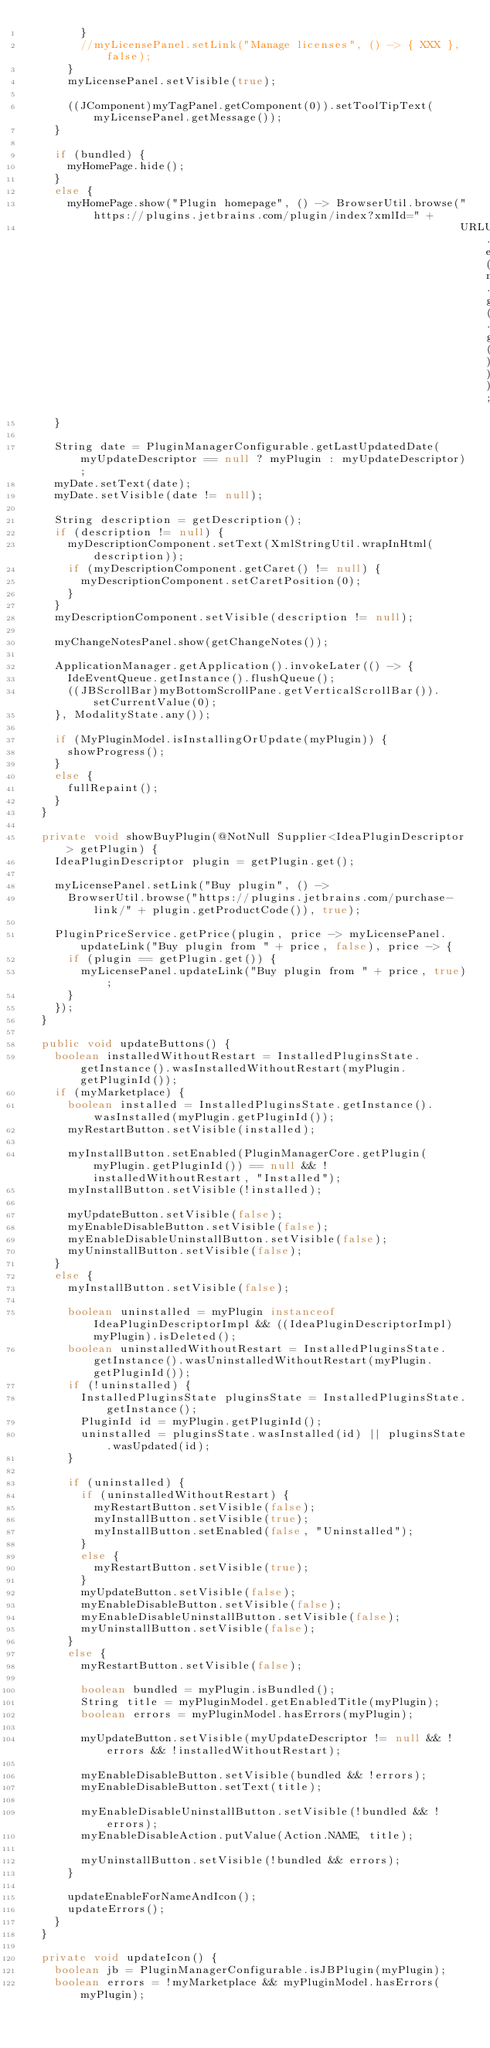<code> <loc_0><loc_0><loc_500><loc_500><_Java_>        }
        //myLicensePanel.setLink("Manage licenses", () -> { XXX }, false);
      }
      myLicensePanel.setVisible(true);

      ((JComponent)myTagPanel.getComponent(0)).setToolTipText(myLicensePanel.getMessage());
    }

    if (bundled) {
      myHomePage.hide();
    }
    else {
      myHomePage.show("Plugin homepage", () -> BrowserUtil.browse("https://plugins.jetbrains.com/plugin/index?xmlId=" +
                                                                  URLUtil.encodeURIComponent(myPlugin.getPluginId().getIdString())));
    }

    String date = PluginManagerConfigurable.getLastUpdatedDate(myUpdateDescriptor == null ? myPlugin : myUpdateDescriptor);
    myDate.setText(date);
    myDate.setVisible(date != null);

    String description = getDescription();
    if (description != null) {
      myDescriptionComponent.setText(XmlStringUtil.wrapInHtml(description));
      if (myDescriptionComponent.getCaret() != null) {
        myDescriptionComponent.setCaretPosition(0);
      }
    }
    myDescriptionComponent.setVisible(description != null);

    myChangeNotesPanel.show(getChangeNotes());

    ApplicationManager.getApplication().invokeLater(() -> {
      IdeEventQueue.getInstance().flushQueue();
      ((JBScrollBar)myBottomScrollPane.getVerticalScrollBar()).setCurrentValue(0);
    }, ModalityState.any());

    if (MyPluginModel.isInstallingOrUpdate(myPlugin)) {
      showProgress();
    }
    else {
      fullRepaint();
    }
  }

  private void showBuyPlugin(@NotNull Supplier<IdeaPluginDescriptor> getPlugin) {
    IdeaPluginDescriptor plugin = getPlugin.get();

    myLicensePanel.setLink("Buy plugin", () ->
      BrowserUtil.browse("https://plugins.jetbrains.com/purchase-link/" + plugin.getProductCode()), true);

    PluginPriceService.getPrice(plugin, price -> myLicensePanel.updateLink("Buy plugin from " + price, false), price -> {
      if (plugin == getPlugin.get()) {
        myLicensePanel.updateLink("Buy plugin from " + price, true);
      }
    });
  }

  public void updateButtons() {
    boolean installedWithoutRestart = InstalledPluginsState.getInstance().wasInstalledWithoutRestart(myPlugin.getPluginId());
    if (myMarketplace) {
      boolean installed = InstalledPluginsState.getInstance().wasInstalled(myPlugin.getPluginId());
      myRestartButton.setVisible(installed);

      myInstallButton.setEnabled(PluginManagerCore.getPlugin(myPlugin.getPluginId()) == null && !installedWithoutRestart, "Installed");
      myInstallButton.setVisible(!installed);

      myUpdateButton.setVisible(false);
      myEnableDisableButton.setVisible(false);
      myEnableDisableUninstallButton.setVisible(false);
      myUninstallButton.setVisible(false);
    }
    else {
      myInstallButton.setVisible(false);

      boolean uninstalled = myPlugin instanceof IdeaPluginDescriptorImpl && ((IdeaPluginDescriptorImpl)myPlugin).isDeleted();
      boolean uninstalledWithoutRestart = InstalledPluginsState.getInstance().wasUninstalledWithoutRestart(myPlugin.getPluginId());
      if (!uninstalled) {
        InstalledPluginsState pluginsState = InstalledPluginsState.getInstance();
        PluginId id = myPlugin.getPluginId();
        uninstalled = pluginsState.wasInstalled(id) || pluginsState.wasUpdated(id);
      }

      if (uninstalled) {
        if (uninstalledWithoutRestart) {
          myRestartButton.setVisible(false);
          myInstallButton.setVisible(true);
          myInstallButton.setEnabled(false, "Uninstalled");
        }
        else {
          myRestartButton.setVisible(true);
        }
        myUpdateButton.setVisible(false);
        myEnableDisableButton.setVisible(false);
        myEnableDisableUninstallButton.setVisible(false);
        myUninstallButton.setVisible(false);
      }
      else {
        myRestartButton.setVisible(false);

        boolean bundled = myPlugin.isBundled();
        String title = myPluginModel.getEnabledTitle(myPlugin);
        boolean errors = myPluginModel.hasErrors(myPlugin);

        myUpdateButton.setVisible(myUpdateDescriptor != null && !errors && !installedWithoutRestart);

        myEnableDisableButton.setVisible(bundled && !errors);
        myEnableDisableButton.setText(title);

        myEnableDisableUninstallButton.setVisible(!bundled && !errors);
        myEnableDisableAction.putValue(Action.NAME, title);

        myUninstallButton.setVisible(!bundled && errors);
      }

      updateEnableForNameAndIcon();
      updateErrors();
    }
  }

  private void updateIcon() {
    boolean jb = PluginManagerConfigurable.isJBPlugin(myPlugin);
    boolean errors = !myMarketplace && myPluginModel.hasErrors(myPlugin);
</code> 